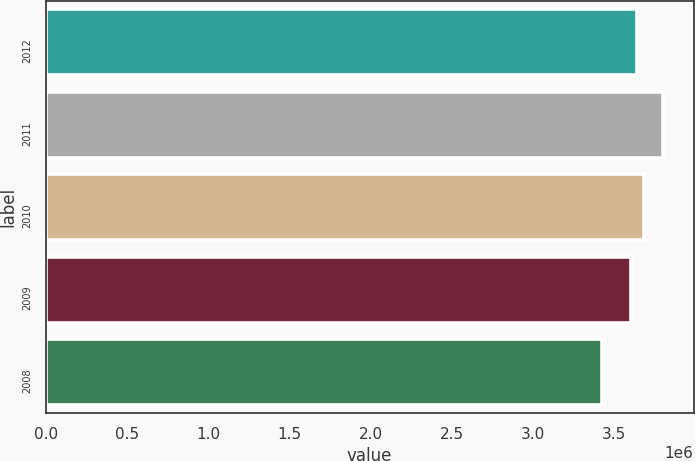Convert chart. <chart><loc_0><loc_0><loc_500><loc_500><bar_chart><fcel>2012<fcel>2011<fcel>2010<fcel>2009<fcel>2008<nl><fcel>3.6444e+06<fcel>3.8e+06<fcel>3.6818e+06<fcel>3.607e+06<fcel>3.426e+06<nl></chart> 